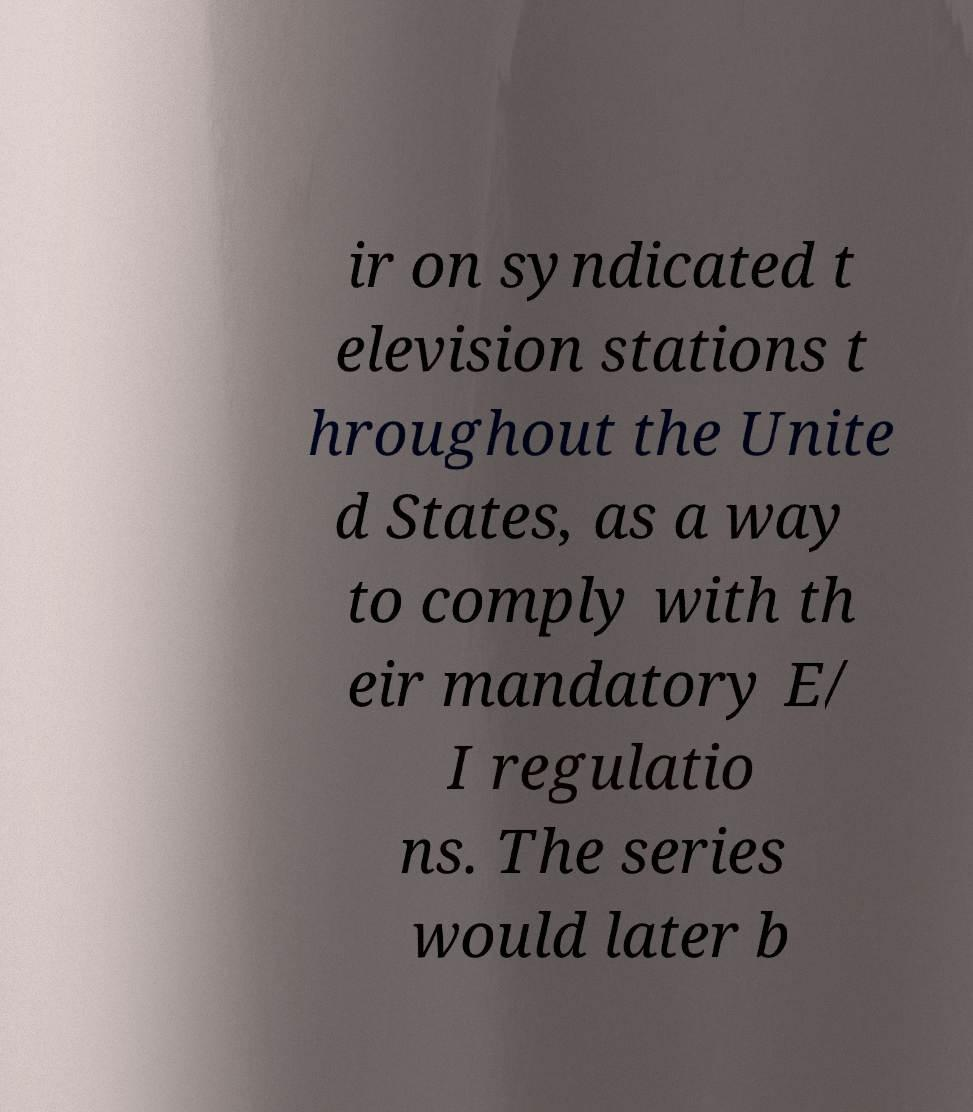What messages or text are displayed in this image? I need them in a readable, typed format. ir on syndicated t elevision stations t hroughout the Unite d States, as a way to comply with th eir mandatory E/ I regulatio ns. The series would later b 